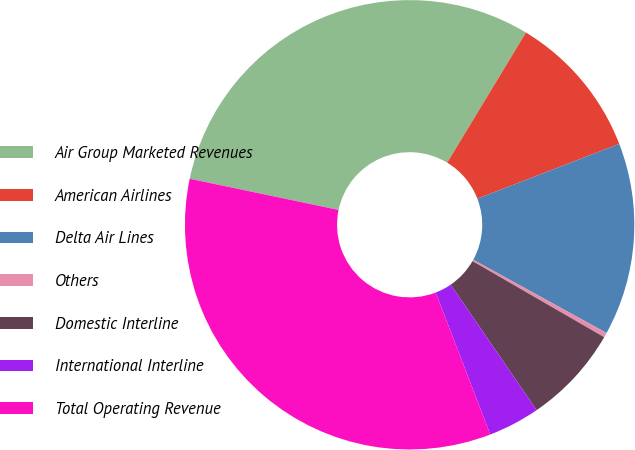Convert chart. <chart><loc_0><loc_0><loc_500><loc_500><pie_chart><fcel>Air Group Marketed Revenues<fcel>American Airlines<fcel>Delta Air Lines<fcel>Others<fcel>Domestic Interline<fcel>International Interline<fcel>Total Operating Revenue<nl><fcel>30.38%<fcel>10.48%<fcel>13.86%<fcel>0.34%<fcel>7.1%<fcel>3.72%<fcel>34.13%<nl></chart> 